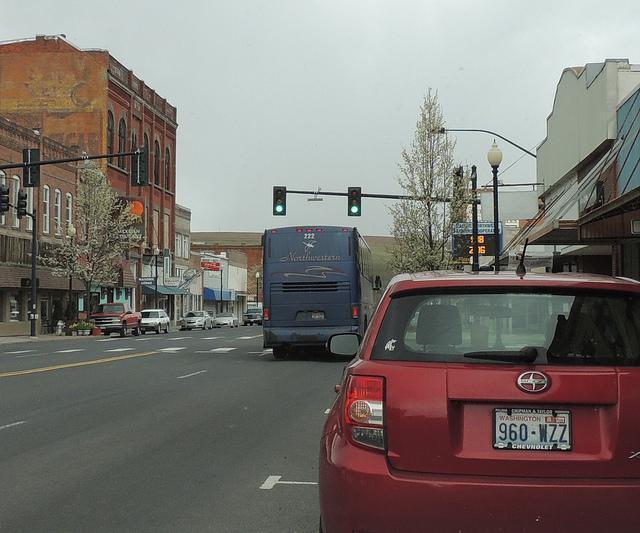How many buses can be seen?
Give a very brief answer. 1. 